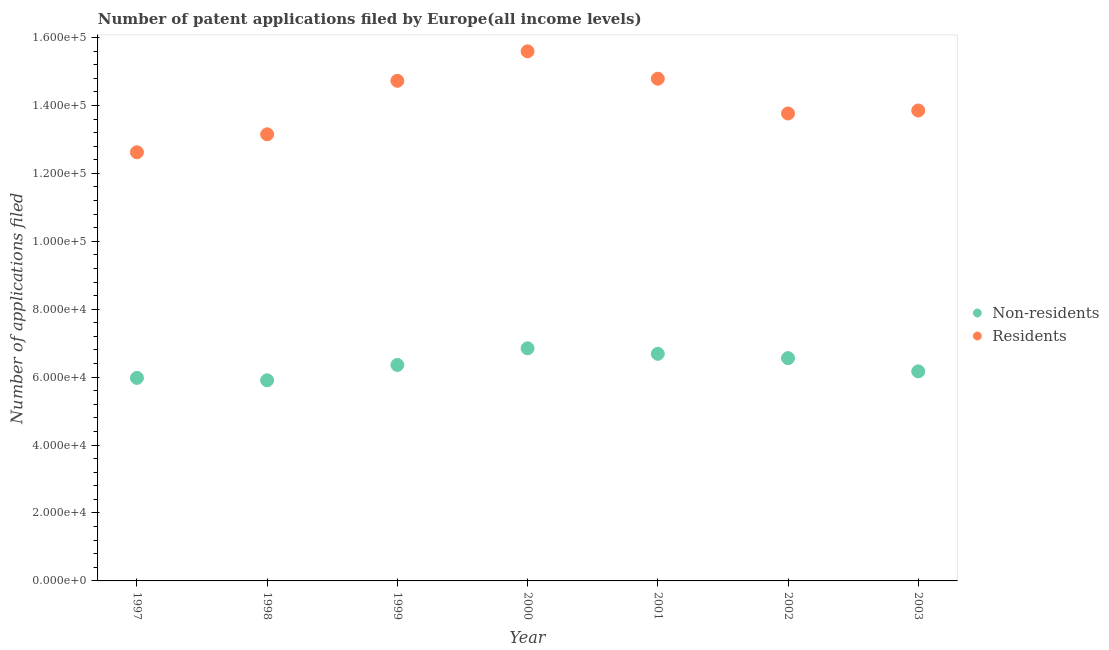How many different coloured dotlines are there?
Give a very brief answer. 2. What is the number of patent applications by residents in 1999?
Provide a short and direct response. 1.47e+05. Across all years, what is the maximum number of patent applications by residents?
Your answer should be compact. 1.56e+05. Across all years, what is the minimum number of patent applications by non residents?
Offer a terse response. 5.91e+04. In which year was the number of patent applications by residents minimum?
Keep it short and to the point. 1997. What is the total number of patent applications by non residents in the graph?
Give a very brief answer. 4.45e+05. What is the difference between the number of patent applications by non residents in 2000 and that in 2001?
Provide a short and direct response. 1619. What is the difference between the number of patent applications by non residents in 1997 and the number of patent applications by residents in 2003?
Provide a short and direct response. -7.87e+04. What is the average number of patent applications by residents per year?
Give a very brief answer. 1.41e+05. In the year 1999, what is the difference between the number of patent applications by residents and number of patent applications by non residents?
Offer a very short reply. 8.37e+04. In how many years, is the number of patent applications by non residents greater than 32000?
Ensure brevity in your answer.  7. What is the ratio of the number of patent applications by residents in 2000 to that in 2001?
Your answer should be compact. 1.05. Is the number of patent applications by residents in 1999 less than that in 2000?
Provide a succinct answer. Yes. Is the difference between the number of patent applications by non residents in 2001 and 2003 greater than the difference between the number of patent applications by residents in 2001 and 2003?
Provide a short and direct response. No. What is the difference between the highest and the second highest number of patent applications by non residents?
Your answer should be very brief. 1619. What is the difference between the highest and the lowest number of patent applications by non residents?
Provide a succinct answer. 9422. Is the sum of the number of patent applications by non residents in 1997 and 2000 greater than the maximum number of patent applications by residents across all years?
Offer a terse response. No. Is the number of patent applications by non residents strictly less than the number of patent applications by residents over the years?
Provide a short and direct response. Yes. Does the graph contain grids?
Provide a succinct answer. No. Where does the legend appear in the graph?
Your answer should be compact. Center right. How many legend labels are there?
Ensure brevity in your answer.  2. How are the legend labels stacked?
Provide a short and direct response. Vertical. What is the title of the graph?
Ensure brevity in your answer.  Number of patent applications filed by Europe(all income levels). Does "Lowest 10% of population" appear as one of the legend labels in the graph?
Give a very brief answer. No. What is the label or title of the X-axis?
Ensure brevity in your answer.  Year. What is the label or title of the Y-axis?
Make the answer very short. Number of applications filed. What is the Number of applications filed in Non-residents in 1997?
Your response must be concise. 5.98e+04. What is the Number of applications filed of Residents in 1997?
Offer a very short reply. 1.26e+05. What is the Number of applications filed of Non-residents in 1998?
Your answer should be very brief. 5.91e+04. What is the Number of applications filed of Residents in 1998?
Offer a very short reply. 1.31e+05. What is the Number of applications filed in Non-residents in 1999?
Ensure brevity in your answer.  6.36e+04. What is the Number of applications filed in Residents in 1999?
Provide a succinct answer. 1.47e+05. What is the Number of applications filed of Non-residents in 2000?
Provide a short and direct response. 6.85e+04. What is the Number of applications filed in Residents in 2000?
Your response must be concise. 1.56e+05. What is the Number of applications filed of Non-residents in 2001?
Give a very brief answer. 6.69e+04. What is the Number of applications filed in Residents in 2001?
Provide a short and direct response. 1.48e+05. What is the Number of applications filed in Non-residents in 2002?
Keep it short and to the point. 6.56e+04. What is the Number of applications filed of Residents in 2002?
Your response must be concise. 1.38e+05. What is the Number of applications filed of Non-residents in 2003?
Offer a terse response. 6.17e+04. What is the Number of applications filed of Residents in 2003?
Give a very brief answer. 1.39e+05. Across all years, what is the maximum Number of applications filed of Non-residents?
Offer a very short reply. 6.85e+04. Across all years, what is the maximum Number of applications filed in Residents?
Provide a succinct answer. 1.56e+05. Across all years, what is the minimum Number of applications filed in Non-residents?
Make the answer very short. 5.91e+04. Across all years, what is the minimum Number of applications filed in Residents?
Your answer should be compact. 1.26e+05. What is the total Number of applications filed in Non-residents in the graph?
Keep it short and to the point. 4.45e+05. What is the total Number of applications filed of Residents in the graph?
Ensure brevity in your answer.  9.85e+05. What is the difference between the Number of applications filed of Non-residents in 1997 and that in 1998?
Give a very brief answer. 711. What is the difference between the Number of applications filed of Residents in 1997 and that in 1998?
Offer a very short reply. -5285. What is the difference between the Number of applications filed in Non-residents in 1997 and that in 1999?
Provide a short and direct response. -3816. What is the difference between the Number of applications filed of Residents in 1997 and that in 1999?
Your response must be concise. -2.10e+04. What is the difference between the Number of applications filed in Non-residents in 1997 and that in 2000?
Your answer should be very brief. -8711. What is the difference between the Number of applications filed in Residents in 1997 and that in 2000?
Your answer should be compact. -2.97e+04. What is the difference between the Number of applications filed of Non-residents in 1997 and that in 2001?
Keep it short and to the point. -7092. What is the difference between the Number of applications filed of Residents in 1997 and that in 2001?
Provide a succinct answer. -2.17e+04. What is the difference between the Number of applications filed of Non-residents in 1997 and that in 2002?
Make the answer very short. -5818. What is the difference between the Number of applications filed of Residents in 1997 and that in 2002?
Keep it short and to the point. -1.14e+04. What is the difference between the Number of applications filed of Non-residents in 1997 and that in 2003?
Your answer should be compact. -1922. What is the difference between the Number of applications filed in Residents in 1997 and that in 2003?
Keep it short and to the point. -1.23e+04. What is the difference between the Number of applications filed of Non-residents in 1998 and that in 1999?
Your answer should be compact. -4527. What is the difference between the Number of applications filed of Residents in 1998 and that in 1999?
Your answer should be very brief. -1.58e+04. What is the difference between the Number of applications filed in Non-residents in 1998 and that in 2000?
Offer a terse response. -9422. What is the difference between the Number of applications filed of Residents in 1998 and that in 2000?
Give a very brief answer. -2.44e+04. What is the difference between the Number of applications filed of Non-residents in 1998 and that in 2001?
Your answer should be very brief. -7803. What is the difference between the Number of applications filed of Residents in 1998 and that in 2001?
Offer a very short reply. -1.64e+04. What is the difference between the Number of applications filed in Non-residents in 1998 and that in 2002?
Your response must be concise. -6529. What is the difference between the Number of applications filed of Residents in 1998 and that in 2002?
Your answer should be very brief. -6139. What is the difference between the Number of applications filed in Non-residents in 1998 and that in 2003?
Provide a short and direct response. -2633. What is the difference between the Number of applications filed in Residents in 1998 and that in 2003?
Your answer should be very brief. -7017. What is the difference between the Number of applications filed in Non-residents in 1999 and that in 2000?
Your response must be concise. -4895. What is the difference between the Number of applications filed in Residents in 1999 and that in 2000?
Offer a very short reply. -8677. What is the difference between the Number of applications filed of Non-residents in 1999 and that in 2001?
Offer a very short reply. -3276. What is the difference between the Number of applications filed in Residents in 1999 and that in 2001?
Provide a succinct answer. -616. What is the difference between the Number of applications filed in Non-residents in 1999 and that in 2002?
Provide a succinct answer. -2002. What is the difference between the Number of applications filed in Residents in 1999 and that in 2002?
Ensure brevity in your answer.  9620. What is the difference between the Number of applications filed of Non-residents in 1999 and that in 2003?
Offer a very short reply. 1894. What is the difference between the Number of applications filed of Residents in 1999 and that in 2003?
Provide a succinct answer. 8742. What is the difference between the Number of applications filed in Non-residents in 2000 and that in 2001?
Provide a succinct answer. 1619. What is the difference between the Number of applications filed of Residents in 2000 and that in 2001?
Your answer should be very brief. 8061. What is the difference between the Number of applications filed of Non-residents in 2000 and that in 2002?
Your response must be concise. 2893. What is the difference between the Number of applications filed of Residents in 2000 and that in 2002?
Your response must be concise. 1.83e+04. What is the difference between the Number of applications filed of Non-residents in 2000 and that in 2003?
Make the answer very short. 6789. What is the difference between the Number of applications filed in Residents in 2000 and that in 2003?
Provide a succinct answer. 1.74e+04. What is the difference between the Number of applications filed of Non-residents in 2001 and that in 2002?
Ensure brevity in your answer.  1274. What is the difference between the Number of applications filed in Residents in 2001 and that in 2002?
Offer a very short reply. 1.02e+04. What is the difference between the Number of applications filed in Non-residents in 2001 and that in 2003?
Your response must be concise. 5170. What is the difference between the Number of applications filed of Residents in 2001 and that in 2003?
Give a very brief answer. 9358. What is the difference between the Number of applications filed of Non-residents in 2002 and that in 2003?
Offer a very short reply. 3896. What is the difference between the Number of applications filed in Residents in 2002 and that in 2003?
Your answer should be compact. -878. What is the difference between the Number of applications filed in Non-residents in 1997 and the Number of applications filed in Residents in 1998?
Make the answer very short. -7.17e+04. What is the difference between the Number of applications filed of Non-residents in 1997 and the Number of applications filed of Residents in 1999?
Offer a terse response. -8.75e+04. What is the difference between the Number of applications filed in Non-residents in 1997 and the Number of applications filed in Residents in 2000?
Offer a terse response. -9.62e+04. What is the difference between the Number of applications filed in Non-residents in 1997 and the Number of applications filed in Residents in 2001?
Ensure brevity in your answer.  -8.81e+04. What is the difference between the Number of applications filed in Non-residents in 1997 and the Number of applications filed in Residents in 2002?
Keep it short and to the point. -7.79e+04. What is the difference between the Number of applications filed in Non-residents in 1997 and the Number of applications filed in Residents in 2003?
Your response must be concise. -7.87e+04. What is the difference between the Number of applications filed of Non-residents in 1998 and the Number of applications filed of Residents in 1999?
Ensure brevity in your answer.  -8.82e+04. What is the difference between the Number of applications filed of Non-residents in 1998 and the Number of applications filed of Residents in 2000?
Provide a short and direct response. -9.69e+04. What is the difference between the Number of applications filed in Non-residents in 1998 and the Number of applications filed in Residents in 2001?
Give a very brief answer. -8.88e+04. What is the difference between the Number of applications filed of Non-residents in 1998 and the Number of applications filed of Residents in 2002?
Your answer should be compact. -7.86e+04. What is the difference between the Number of applications filed of Non-residents in 1998 and the Number of applications filed of Residents in 2003?
Offer a terse response. -7.94e+04. What is the difference between the Number of applications filed in Non-residents in 1999 and the Number of applications filed in Residents in 2000?
Offer a very short reply. -9.23e+04. What is the difference between the Number of applications filed in Non-residents in 1999 and the Number of applications filed in Residents in 2001?
Your answer should be very brief. -8.43e+04. What is the difference between the Number of applications filed of Non-residents in 1999 and the Number of applications filed of Residents in 2002?
Provide a succinct answer. -7.40e+04. What is the difference between the Number of applications filed in Non-residents in 1999 and the Number of applications filed in Residents in 2003?
Provide a short and direct response. -7.49e+04. What is the difference between the Number of applications filed in Non-residents in 2000 and the Number of applications filed in Residents in 2001?
Make the answer very short. -7.94e+04. What is the difference between the Number of applications filed in Non-residents in 2000 and the Number of applications filed in Residents in 2002?
Offer a very short reply. -6.91e+04. What is the difference between the Number of applications filed of Non-residents in 2000 and the Number of applications filed of Residents in 2003?
Your answer should be very brief. -7.00e+04. What is the difference between the Number of applications filed in Non-residents in 2001 and the Number of applications filed in Residents in 2002?
Keep it short and to the point. -7.08e+04. What is the difference between the Number of applications filed in Non-residents in 2001 and the Number of applications filed in Residents in 2003?
Provide a short and direct response. -7.16e+04. What is the difference between the Number of applications filed in Non-residents in 2002 and the Number of applications filed in Residents in 2003?
Provide a short and direct response. -7.29e+04. What is the average Number of applications filed in Non-residents per year?
Offer a very short reply. 6.36e+04. What is the average Number of applications filed in Residents per year?
Your answer should be very brief. 1.41e+05. In the year 1997, what is the difference between the Number of applications filed in Non-residents and Number of applications filed in Residents?
Provide a succinct answer. -6.64e+04. In the year 1998, what is the difference between the Number of applications filed in Non-residents and Number of applications filed in Residents?
Provide a succinct answer. -7.24e+04. In the year 1999, what is the difference between the Number of applications filed in Non-residents and Number of applications filed in Residents?
Provide a succinct answer. -8.37e+04. In the year 2000, what is the difference between the Number of applications filed of Non-residents and Number of applications filed of Residents?
Offer a very short reply. -8.74e+04. In the year 2001, what is the difference between the Number of applications filed of Non-residents and Number of applications filed of Residents?
Make the answer very short. -8.10e+04. In the year 2002, what is the difference between the Number of applications filed of Non-residents and Number of applications filed of Residents?
Keep it short and to the point. -7.20e+04. In the year 2003, what is the difference between the Number of applications filed in Non-residents and Number of applications filed in Residents?
Provide a succinct answer. -7.68e+04. What is the ratio of the Number of applications filed of Residents in 1997 to that in 1998?
Offer a very short reply. 0.96. What is the ratio of the Number of applications filed in Non-residents in 1997 to that in 1999?
Offer a very short reply. 0.94. What is the ratio of the Number of applications filed in Residents in 1997 to that in 1999?
Provide a short and direct response. 0.86. What is the ratio of the Number of applications filed in Non-residents in 1997 to that in 2000?
Offer a very short reply. 0.87. What is the ratio of the Number of applications filed of Residents in 1997 to that in 2000?
Your answer should be very brief. 0.81. What is the ratio of the Number of applications filed in Non-residents in 1997 to that in 2001?
Make the answer very short. 0.89. What is the ratio of the Number of applications filed of Residents in 1997 to that in 2001?
Make the answer very short. 0.85. What is the ratio of the Number of applications filed in Non-residents in 1997 to that in 2002?
Keep it short and to the point. 0.91. What is the ratio of the Number of applications filed in Residents in 1997 to that in 2002?
Your response must be concise. 0.92. What is the ratio of the Number of applications filed in Non-residents in 1997 to that in 2003?
Keep it short and to the point. 0.97. What is the ratio of the Number of applications filed of Residents in 1997 to that in 2003?
Ensure brevity in your answer.  0.91. What is the ratio of the Number of applications filed in Non-residents in 1998 to that in 1999?
Provide a succinct answer. 0.93. What is the ratio of the Number of applications filed of Residents in 1998 to that in 1999?
Keep it short and to the point. 0.89. What is the ratio of the Number of applications filed in Non-residents in 1998 to that in 2000?
Your answer should be very brief. 0.86. What is the ratio of the Number of applications filed in Residents in 1998 to that in 2000?
Give a very brief answer. 0.84. What is the ratio of the Number of applications filed in Non-residents in 1998 to that in 2001?
Provide a short and direct response. 0.88. What is the ratio of the Number of applications filed in Residents in 1998 to that in 2001?
Make the answer very short. 0.89. What is the ratio of the Number of applications filed in Non-residents in 1998 to that in 2002?
Your answer should be very brief. 0.9. What is the ratio of the Number of applications filed in Residents in 1998 to that in 2002?
Your answer should be very brief. 0.96. What is the ratio of the Number of applications filed of Non-residents in 1998 to that in 2003?
Your answer should be compact. 0.96. What is the ratio of the Number of applications filed of Residents in 1998 to that in 2003?
Provide a short and direct response. 0.95. What is the ratio of the Number of applications filed of Non-residents in 1999 to that in 2000?
Offer a very short reply. 0.93. What is the ratio of the Number of applications filed in Residents in 1999 to that in 2000?
Your response must be concise. 0.94. What is the ratio of the Number of applications filed in Non-residents in 1999 to that in 2001?
Your answer should be very brief. 0.95. What is the ratio of the Number of applications filed of Residents in 1999 to that in 2001?
Keep it short and to the point. 1. What is the ratio of the Number of applications filed of Non-residents in 1999 to that in 2002?
Your answer should be compact. 0.97. What is the ratio of the Number of applications filed in Residents in 1999 to that in 2002?
Your response must be concise. 1.07. What is the ratio of the Number of applications filed of Non-residents in 1999 to that in 2003?
Ensure brevity in your answer.  1.03. What is the ratio of the Number of applications filed of Residents in 1999 to that in 2003?
Ensure brevity in your answer.  1.06. What is the ratio of the Number of applications filed in Non-residents in 2000 to that in 2001?
Your answer should be compact. 1.02. What is the ratio of the Number of applications filed in Residents in 2000 to that in 2001?
Provide a short and direct response. 1.05. What is the ratio of the Number of applications filed of Non-residents in 2000 to that in 2002?
Your answer should be compact. 1.04. What is the ratio of the Number of applications filed in Residents in 2000 to that in 2002?
Make the answer very short. 1.13. What is the ratio of the Number of applications filed of Non-residents in 2000 to that in 2003?
Offer a very short reply. 1.11. What is the ratio of the Number of applications filed of Residents in 2000 to that in 2003?
Make the answer very short. 1.13. What is the ratio of the Number of applications filed in Non-residents in 2001 to that in 2002?
Your answer should be compact. 1.02. What is the ratio of the Number of applications filed of Residents in 2001 to that in 2002?
Give a very brief answer. 1.07. What is the ratio of the Number of applications filed of Non-residents in 2001 to that in 2003?
Your answer should be compact. 1.08. What is the ratio of the Number of applications filed in Residents in 2001 to that in 2003?
Provide a short and direct response. 1.07. What is the ratio of the Number of applications filed in Non-residents in 2002 to that in 2003?
Offer a very short reply. 1.06. What is the ratio of the Number of applications filed of Residents in 2002 to that in 2003?
Give a very brief answer. 0.99. What is the difference between the highest and the second highest Number of applications filed of Non-residents?
Your answer should be compact. 1619. What is the difference between the highest and the second highest Number of applications filed of Residents?
Provide a short and direct response. 8061. What is the difference between the highest and the lowest Number of applications filed of Non-residents?
Keep it short and to the point. 9422. What is the difference between the highest and the lowest Number of applications filed in Residents?
Provide a short and direct response. 2.97e+04. 